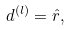<formula> <loc_0><loc_0><loc_500><loc_500>d ^ { ( l ) } = \hat { r } ,</formula> 